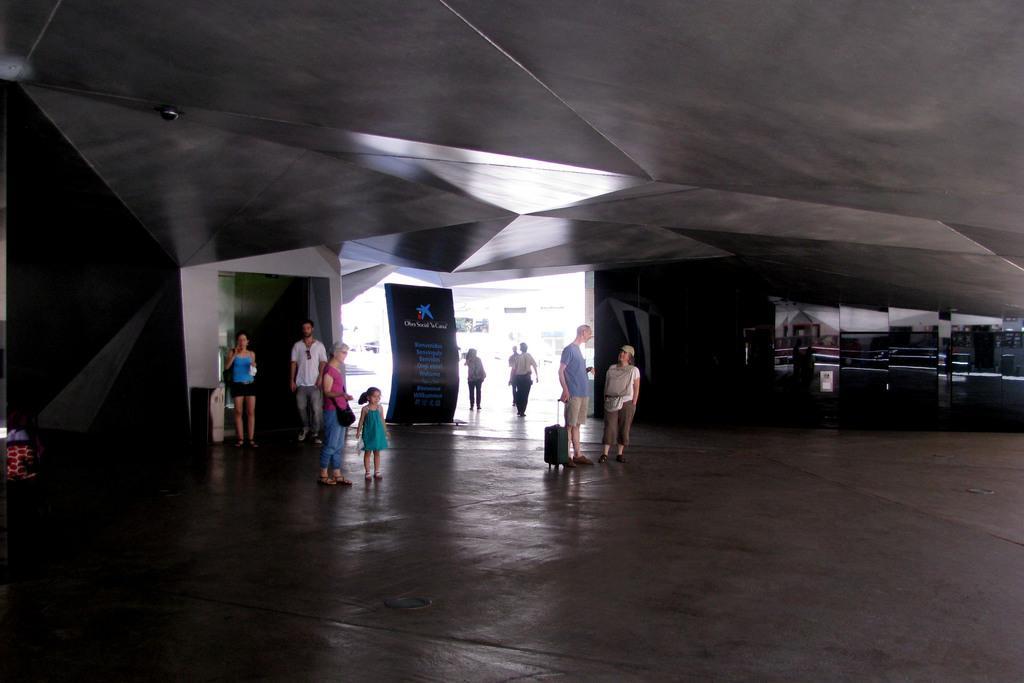Can you describe this image briefly? This image is clicked inside a room. There are few people standing on the ground. In the center there is a man holding a trolley bag. There are banners in the room. In the background there is an entrance. At the top there is a ceiling. 